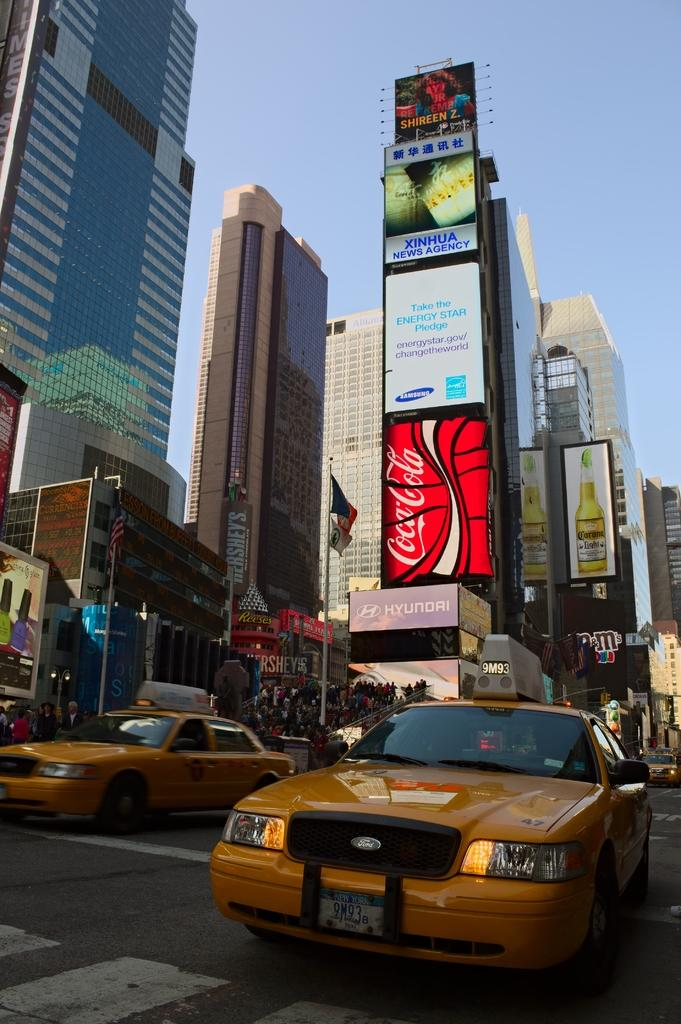Provide a one-sentence caption for the provided image. a city street with FORD taxis, high buildings, ads on signage for Coca Cola, Xinhua, Corona Light, Shireen Z., & Hyundai. 